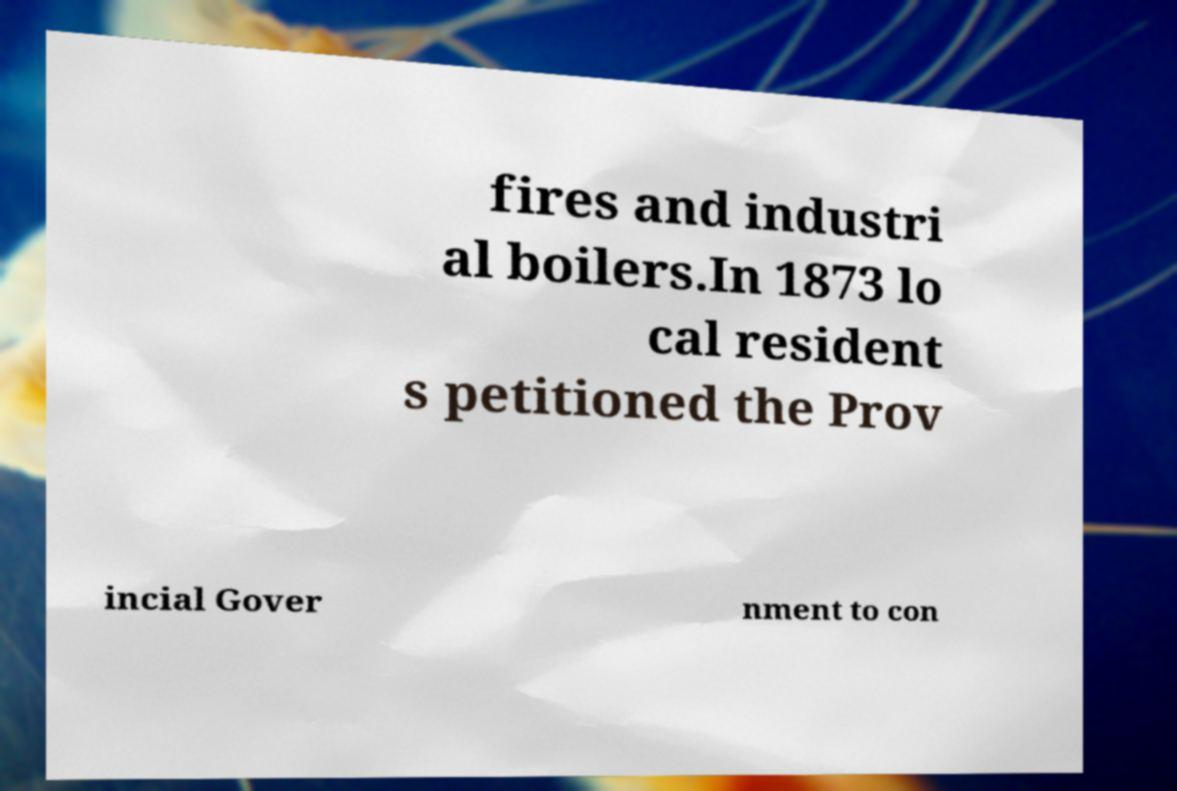There's text embedded in this image that I need extracted. Can you transcribe it verbatim? fires and industri al boilers.In 1873 lo cal resident s petitioned the Prov incial Gover nment to con 